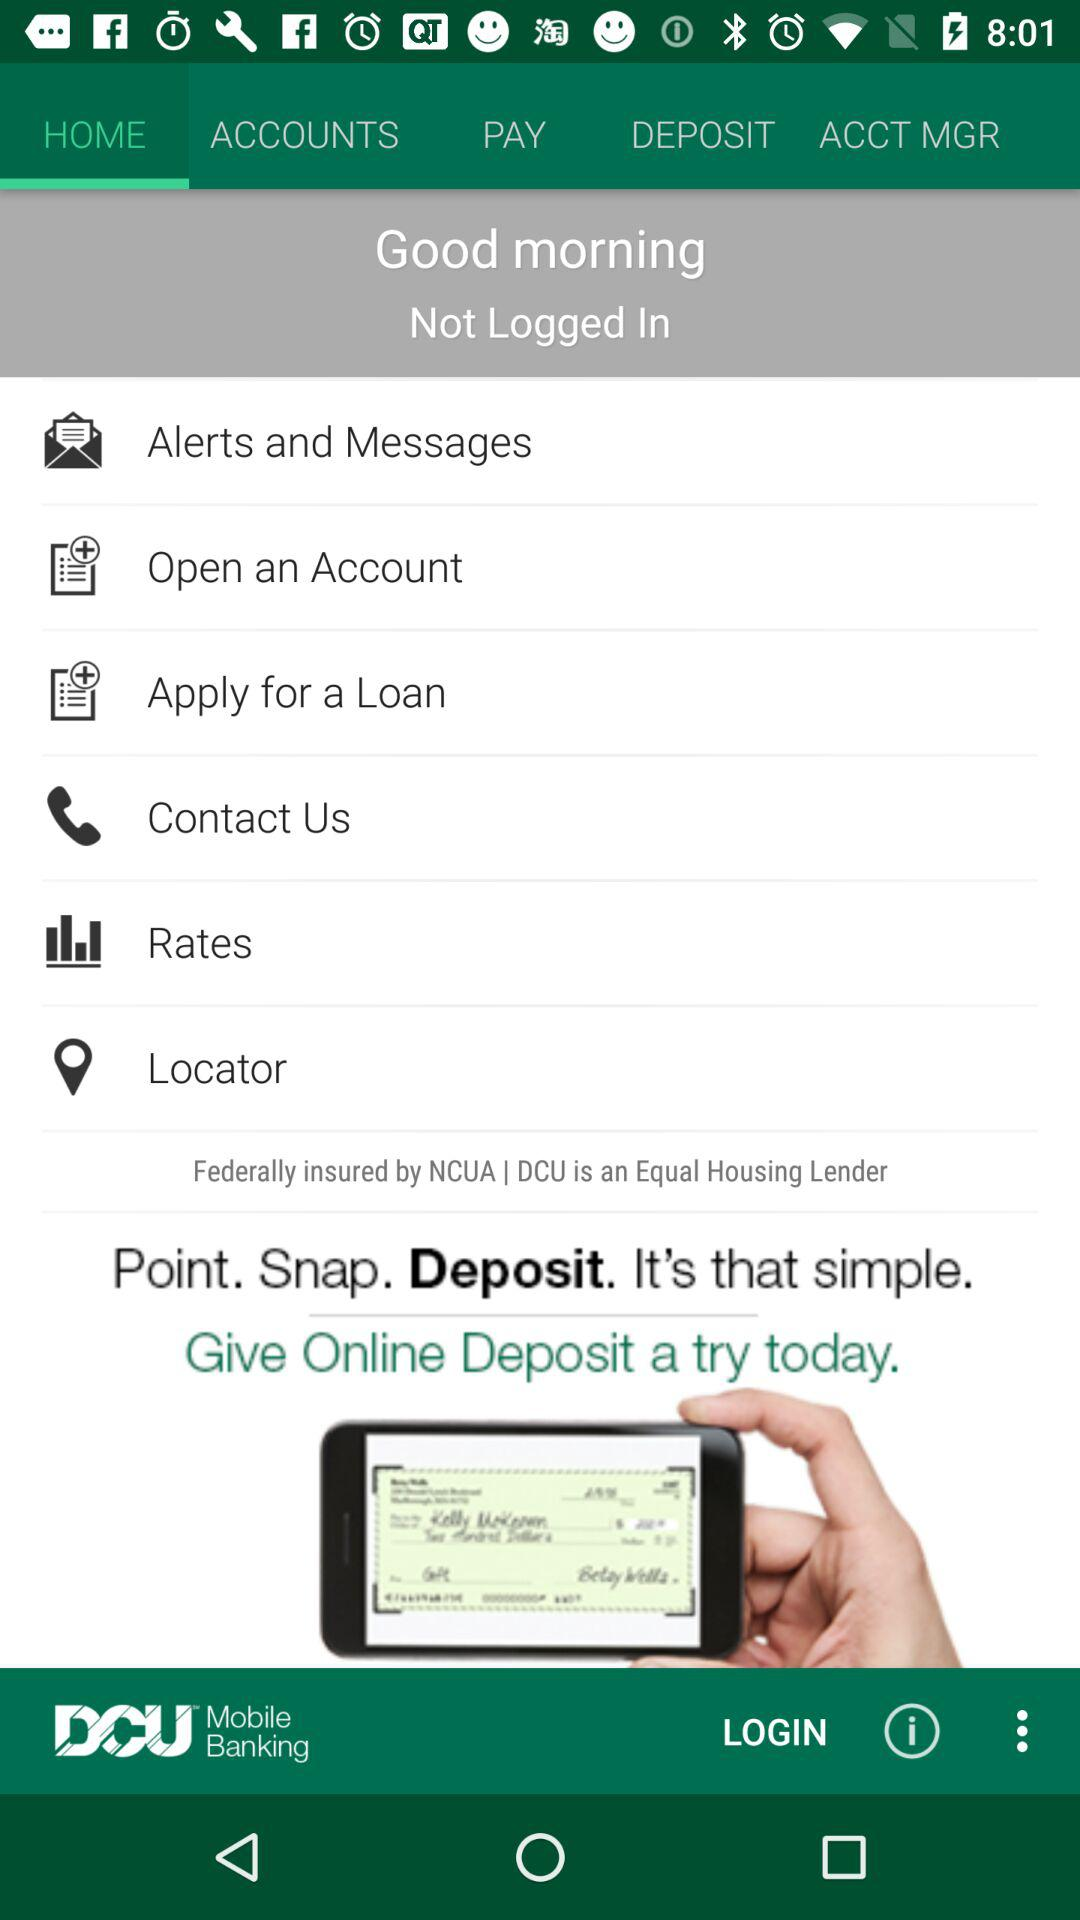Which tab is selected? The selected tab is "HOME". 